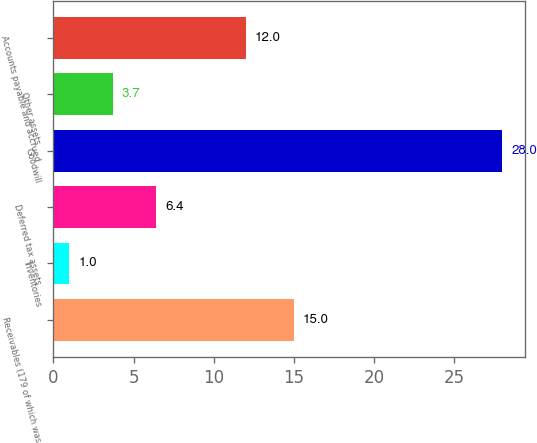Convert chart to OTSL. <chart><loc_0><loc_0><loc_500><loc_500><bar_chart><fcel>Receivables (179 of which was<fcel>Inventories<fcel>Deferred tax assets<fcel>Goodwill<fcel>Other assets<fcel>Accounts payable and accrued<nl><fcel>15<fcel>1<fcel>6.4<fcel>28<fcel>3.7<fcel>12<nl></chart> 